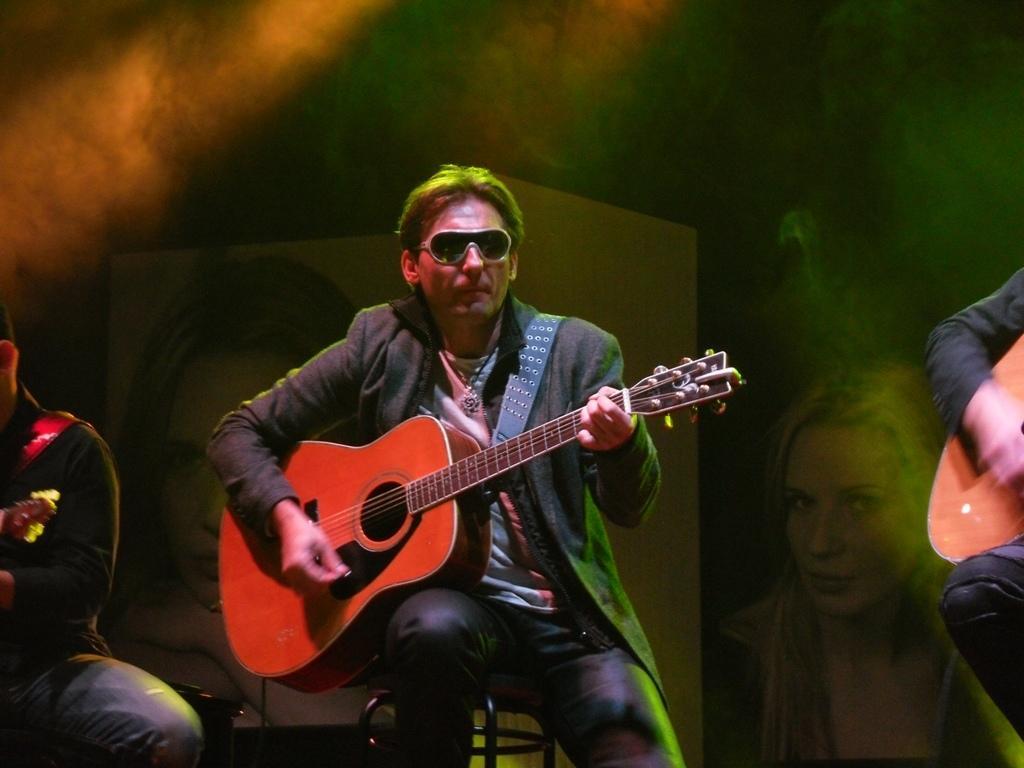How would you summarize this image in a sentence or two? In this image, In the middle there is a man sitting on a chair which is in black color he is holding a music instrument which is in orange color, In the right side there is a person sitting and holding a object which is in yellow color, In the left side there is a man siting, In the background there is a white color wall and there is a girl picture on the wall. 